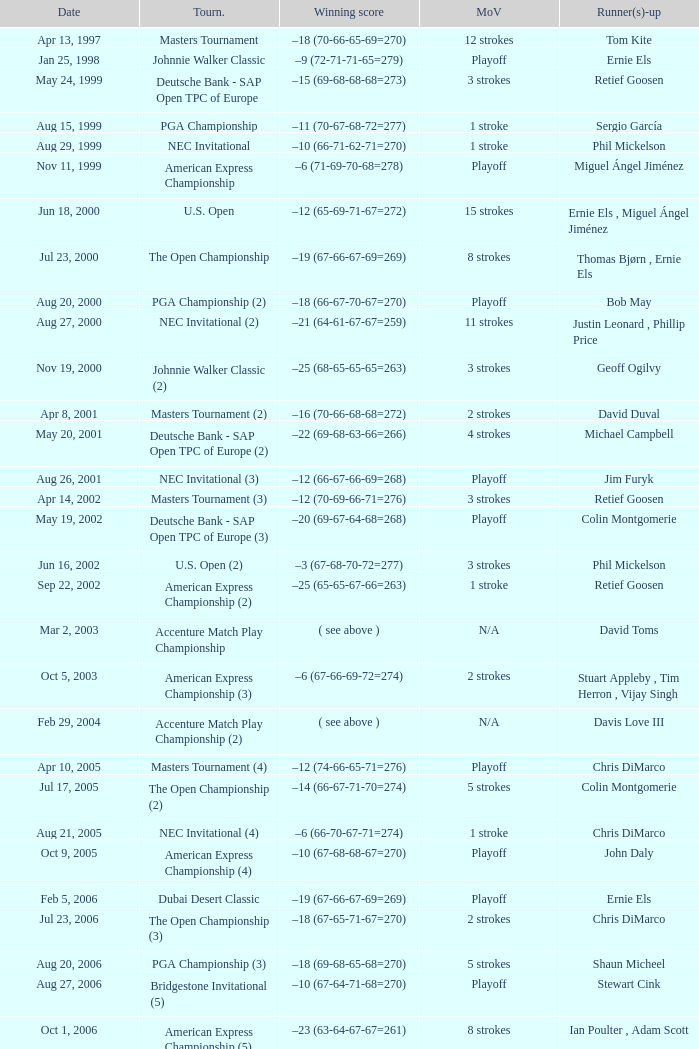Who is Runner(s)-up that has a Date of may 24, 1999? Retief Goosen. 